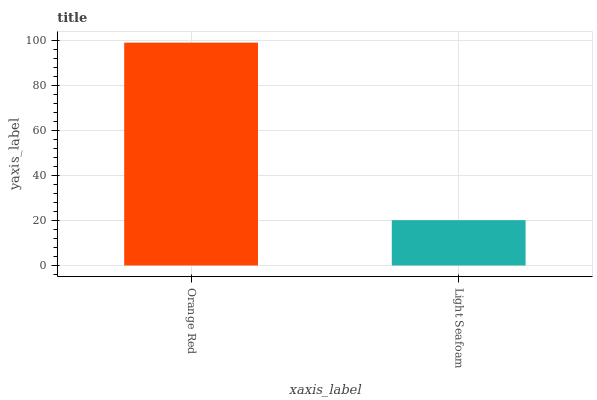Is Light Seafoam the minimum?
Answer yes or no. Yes. Is Orange Red the maximum?
Answer yes or no. Yes. Is Light Seafoam the maximum?
Answer yes or no. No. Is Orange Red greater than Light Seafoam?
Answer yes or no. Yes. Is Light Seafoam less than Orange Red?
Answer yes or no. Yes. Is Light Seafoam greater than Orange Red?
Answer yes or no. No. Is Orange Red less than Light Seafoam?
Answer yes or no. No. Is Orange Red the high median?
Answer yes or no. Yes. Is Light Seafoam the low median?
Answer yes or no. Yes. Is Light Seafoam the high median?
Answer yes or no. No. Is Orange Red the low median?
Answer yes or no. No. 